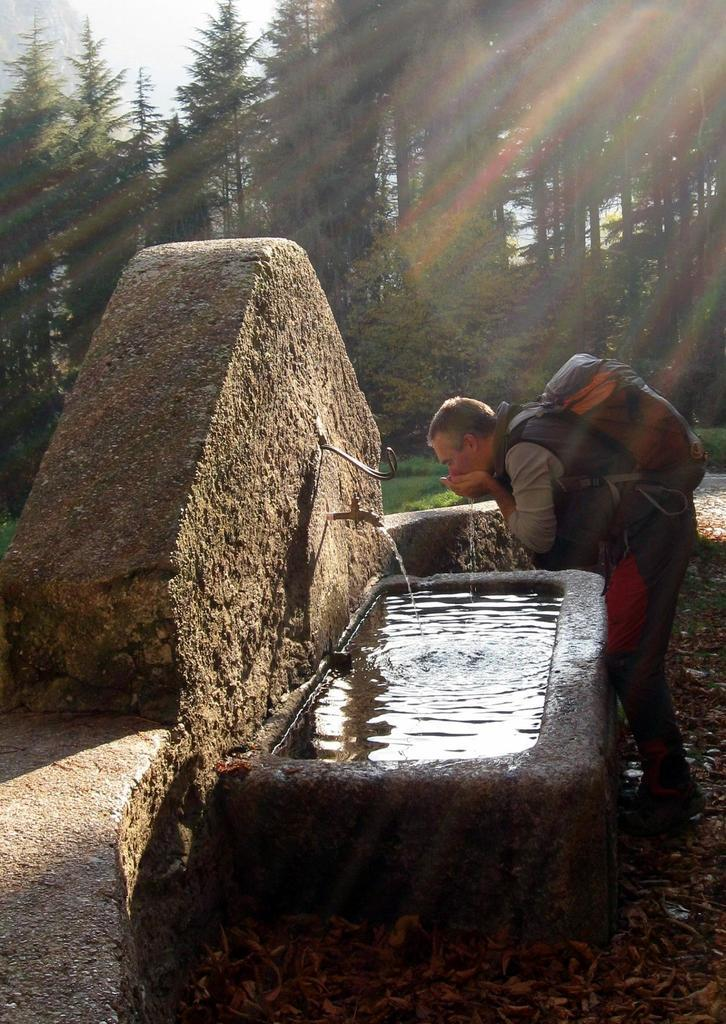What can be found in the image for washing hands? There is a wash basin in the image. What feature is present on the wash basin? There is a tap on the wash basin. Who is present in the image near the wash basin? A person is standing in front of the wash basin. What is the person carrying in the image? The person is carrying a bag. What can be seen in the distance in the image? There are trees in the background of the image. What flavor of crime is the person committing in the image? There is no crime or flavor of crime present in the image; it features a person standing in front of a wash basin. 